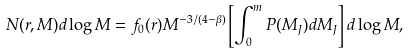<formula> <loc_0><loc_0><loc_500><loc_500>N ( r , M ) d \log M = f _ { 0 } ( r ) M ^ { - 3 / ( 4 - \beta ) } \left [ \int ^ { m } _ { 0 } P ( M _ { J } ) d M _ { J } \right ] d \log M ,</formula> 